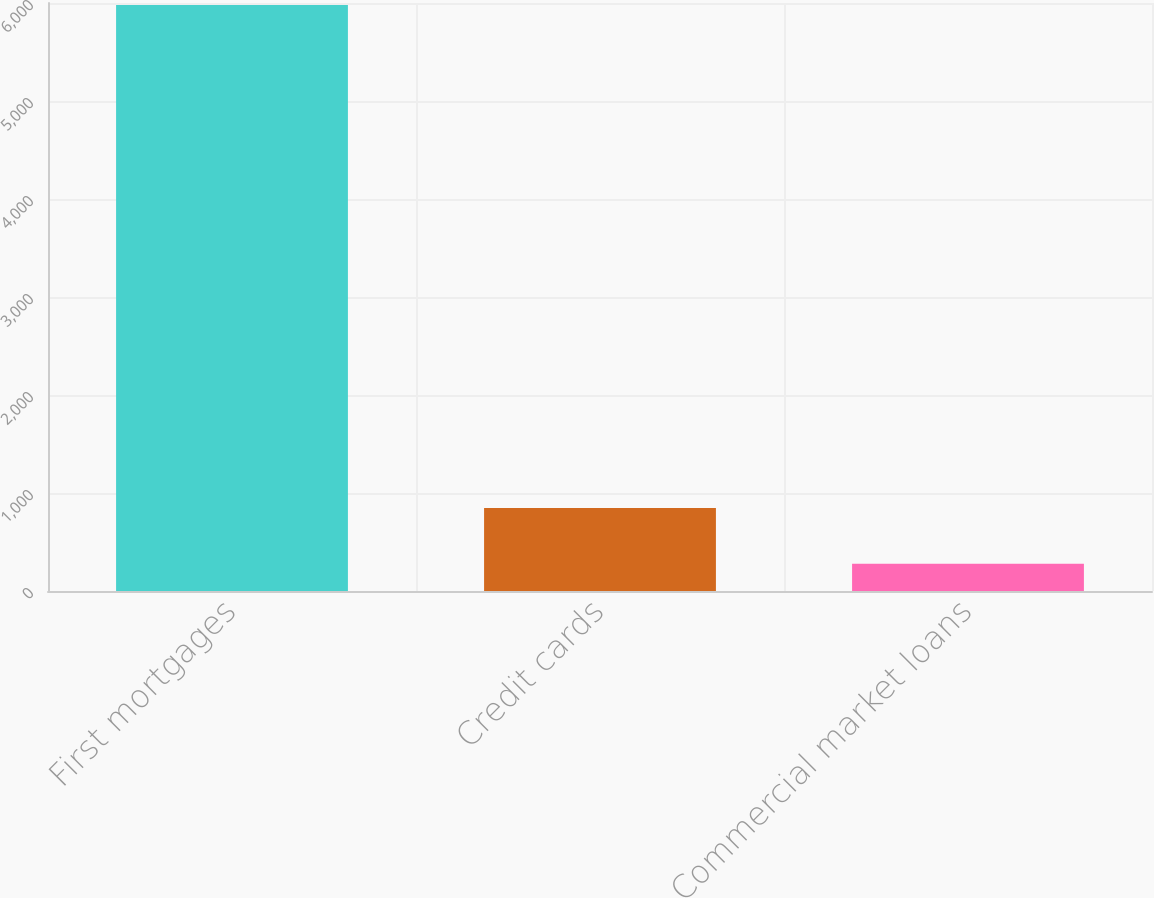Convert chart. <chart><loc_0><loc_0><loc_500><loc_500><bar_chart><fcel>First mortgages<fcel>Credit cards<fcel>Commercial market loans<nl><fcel>5979<fcel>848.1<fcel>278<nl></chart> 